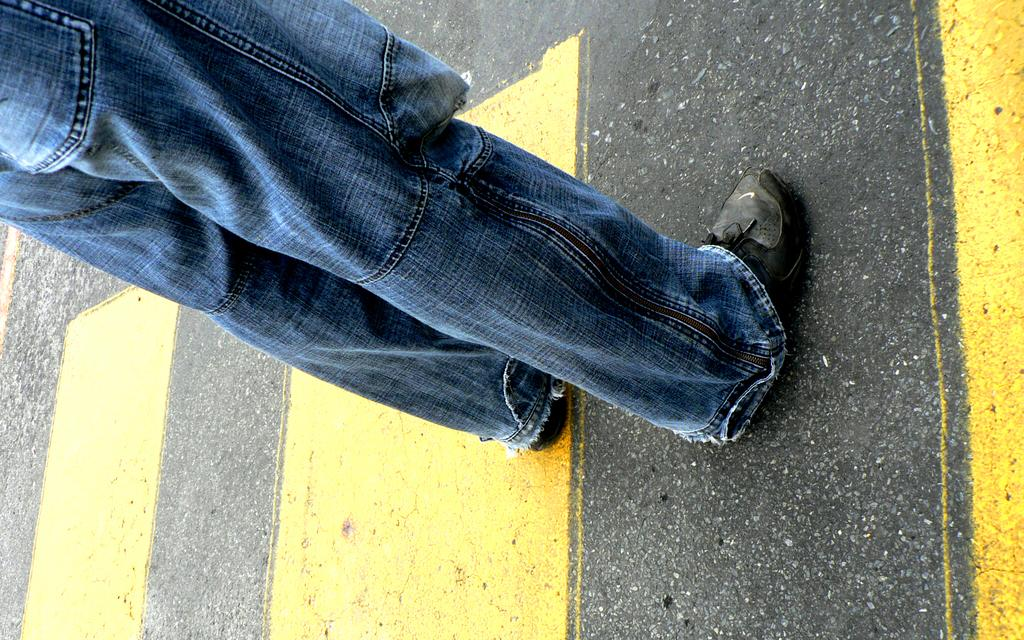What is the main subject of the image? There is a man in the image. What type of clothing is the man wearing? The man is wearing jeans. What type of footwear is the man wearing? The man is wearing black shoes. Where is the man standing in the image? The man is standing on the road. What can be seen in the background of the image? There is a road visible in the image. What type of yoke is the man holding in the image? There is no yoke present in the image; the man is simply standing on the road. 